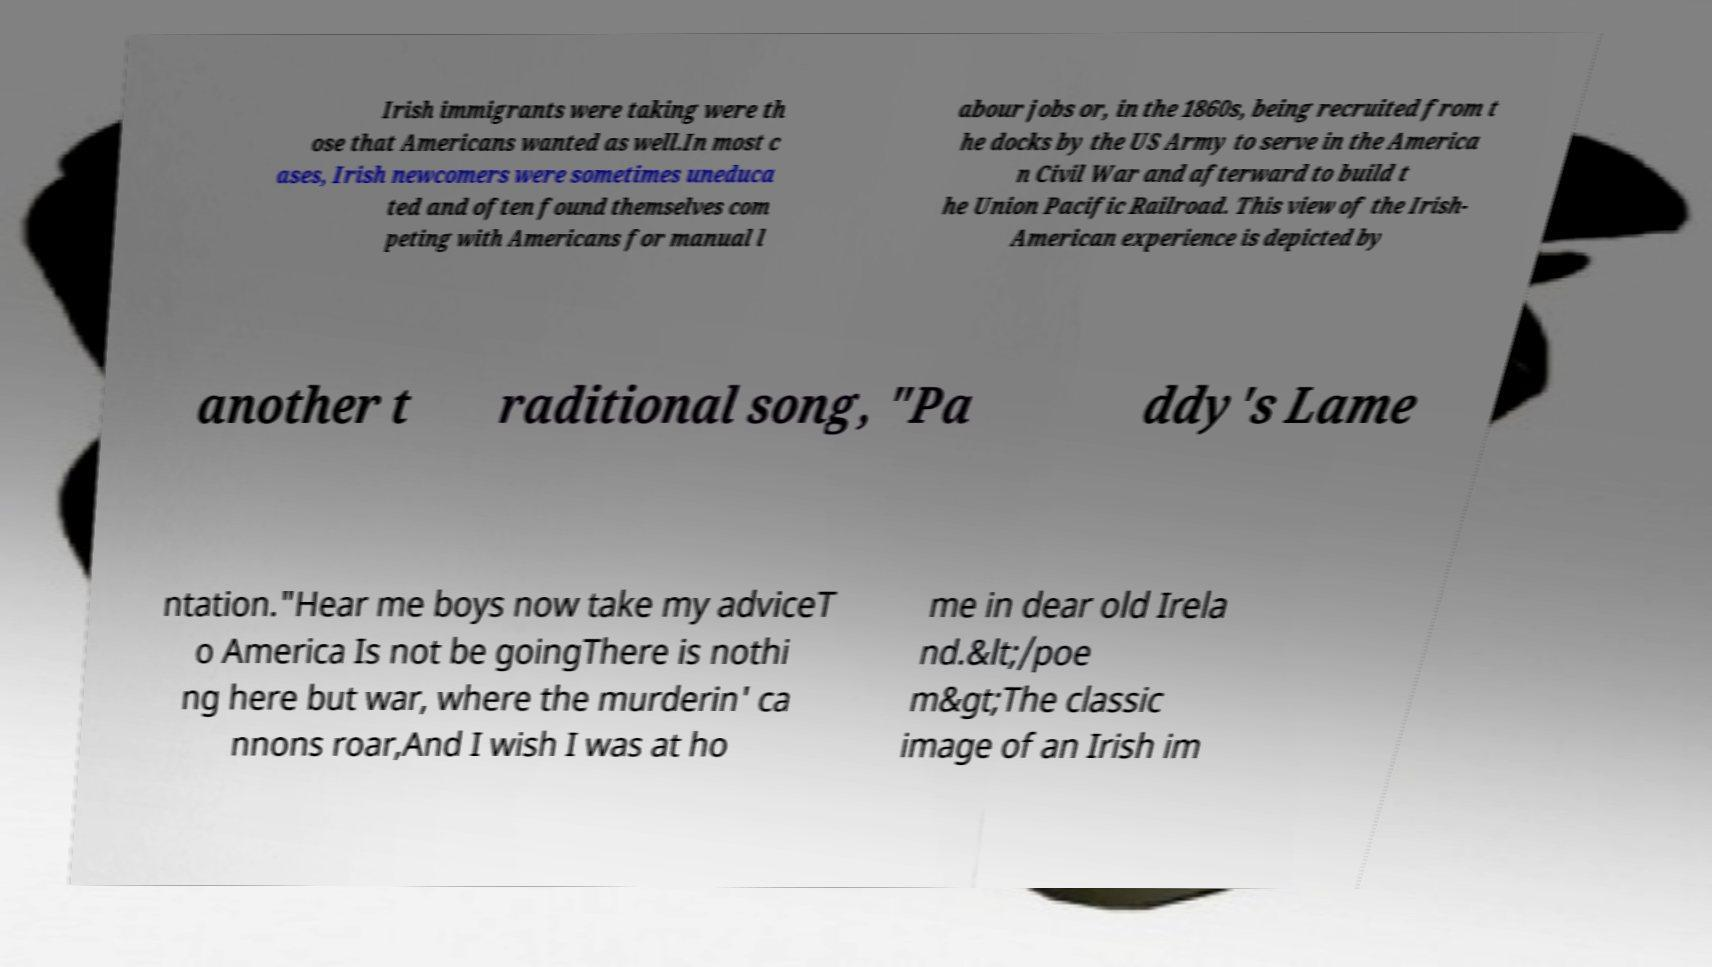Can you read and provide the text displayed in the image?This photo seems to have some interesting text. Can you extract and type it out for me? Irish immigrants were taking were th ose that Americans wanted as well.In most c ases, Irish newcomers were sometimes uneduca ted and often found themselves com peting with Americans for manual l abour jobs or, in the 1860s, being recruited from t he docks by the US Army to serve in the America n Civil War and afterward to build t he Union Pacific Railroad. This view of the Irish- American experience is depicted by another t raditional song, "Pa ddy's Lame ntation."Hear me boys now take my adviceT o America Is not be goingThere is nothi ng here but war, where the murderin' ca nnons roar,And I wish I was at ho me in dear old Irela nd.&lt;/poe m&gt;The classic image of an Irish im 